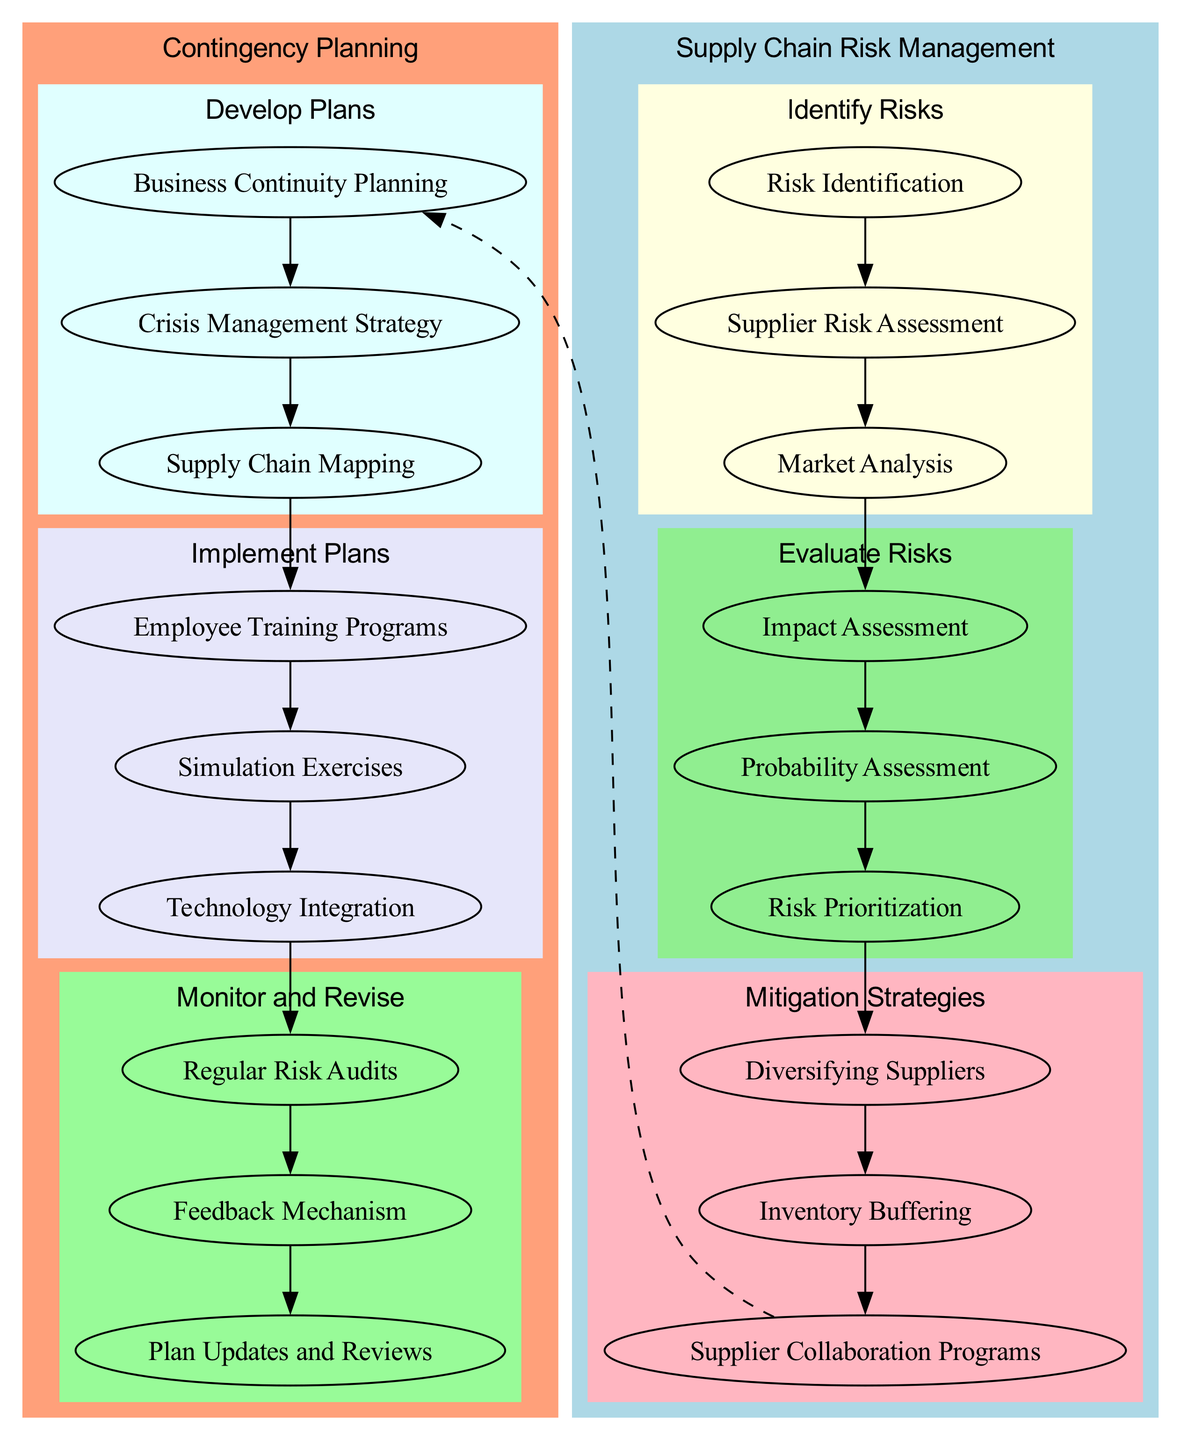What is the first step in Supply Chain Risk Management? The diagram indicates that the first step under Supply Chain Risk Management is "Risk Identification." This is identified directly from the node labeled as the first step in the "Identify Risks" section.
Answer: Risk Identification How many steps are there in the "Evaluate Risks" section? The diagram shows three distinct steps in the "Evaluate Risks" section: "Impact Assessment," "Probability Assessment," and "Risk Prioritization." Hence, counting these yields a total of three steps.
Answer: 3 Which node connects "Supplier Risk Assessment" to "Impact Assessment"? The diagram illustrates that "Supplier Risk Assessment" is connected to "Impact Assessment" via the edge linking the end of the "Identify Risks" section to the beginning of the "Evaluate Risks" section, indicating a flow from one to the other.
Answer: Impact Assessment What is the last step in the "Develop Plans" section? According to the diagram, the last step in the "Develop Plans" section is "Supply Chain Mapping." This is found as the third step in that section, visually connected to the other two steps.
Answer: Supply Chain Mapping Which teams are involved in "Monitor and Revise"? The diagram specifies two teams involved in this section: "Audit Team" and "Risk Management Team." They are noted as the actors responsible for the tasks related to monitoring and revising the plans.
Answer: Audit Team, Risk Management Team How many nodes are in the "Mitigation Strategies" sub-section? The diagram exhibits three nodes in the "Mitigation Strategies" sub-section: "Diversifying Suppliers," "Inventory Buffering," and "Supplier Collaboration Programs." Thus, when counted, there are three nodes in total.
Answer: 3 Which step precedes "Employee Training Programs"? The diagram shows that "Business Continuity Planning" precedes "Employee Training Programs." This relationship is confirmed by the edge that connects the last step of the "Develop Plans" to the first step in the "Implement Plans" section.
Answer: Business Continuity Planning What is the relationship between "Supplier Collaboration Programs" and "Business Continuity Planning"? The diagram indicates that there is a dashed edge connecting "Supplier Collaboration Programs" directly to "Business Continuity Planning." This illustrates an indirect relationship, showing the flow of information between the mitigation strategy and the planning phase.
Answer: Indirect relationship Which actor is responsible for "Simulation Exercises"? The diagram states that "Training Coordinator" is the actor responsible for the step "Simulation Exercises." This is directly referenced under the "Implement Plans" section.
Answer: Training Coordinator 